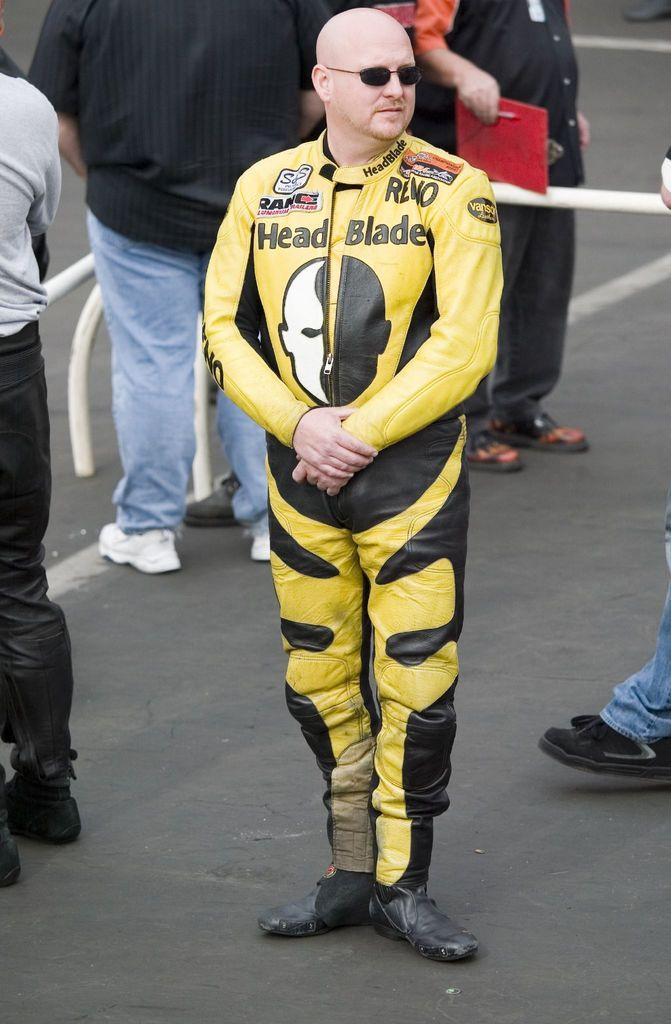Can you describe this image briefly? In this picture, it looks like a man is in the racing suit. Behind the man there is a group of people standing on the road and there are iron grilles. A person is holding a red color object. 